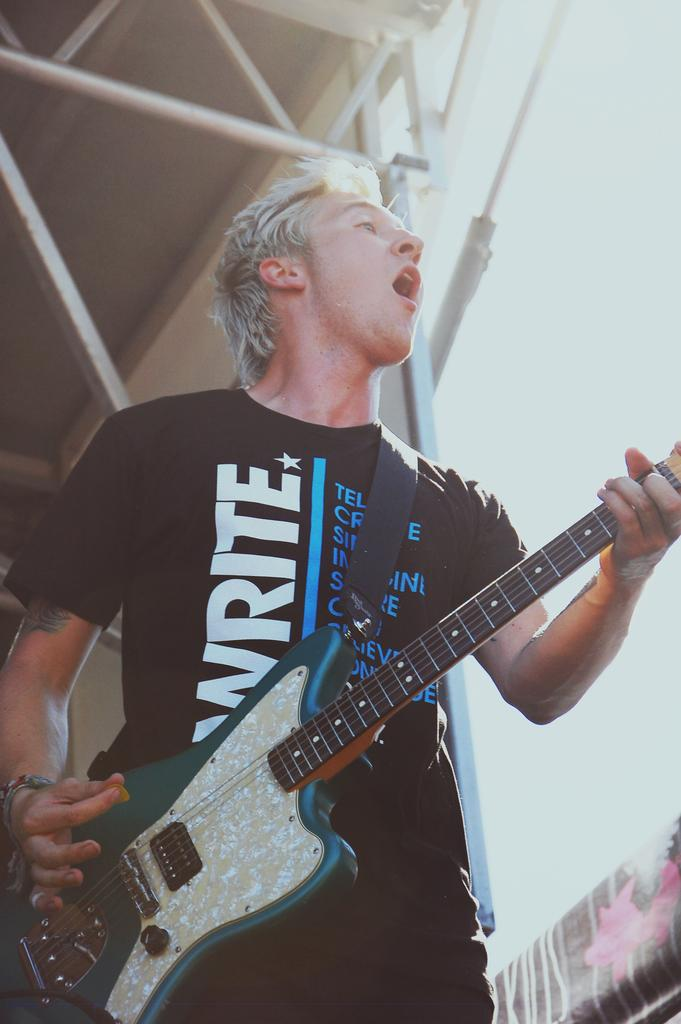What is the main subject of the image? The main subject of the image is a man. What is the man wearing in the image? The man is wearing a black t-shirt in the image. What activity is the man engaged in? The man is playing a guitar in the image. What type of toy can be seen in the man's hand in the image? There is no toy present in the image; the man is playing a guitar. What color is the marble that the man is holding in the image? There is no marble present in the image; the man is playing a guitar. 